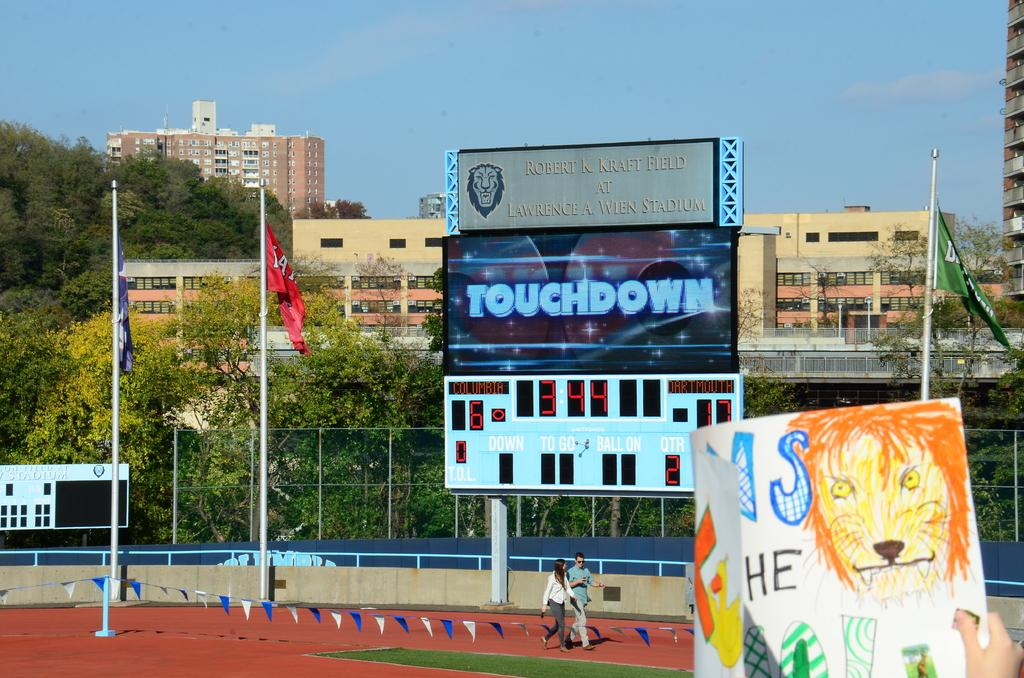Provide a one-sentence caption for the provided image. A football stadium big screen showing the text touchdown on it. 